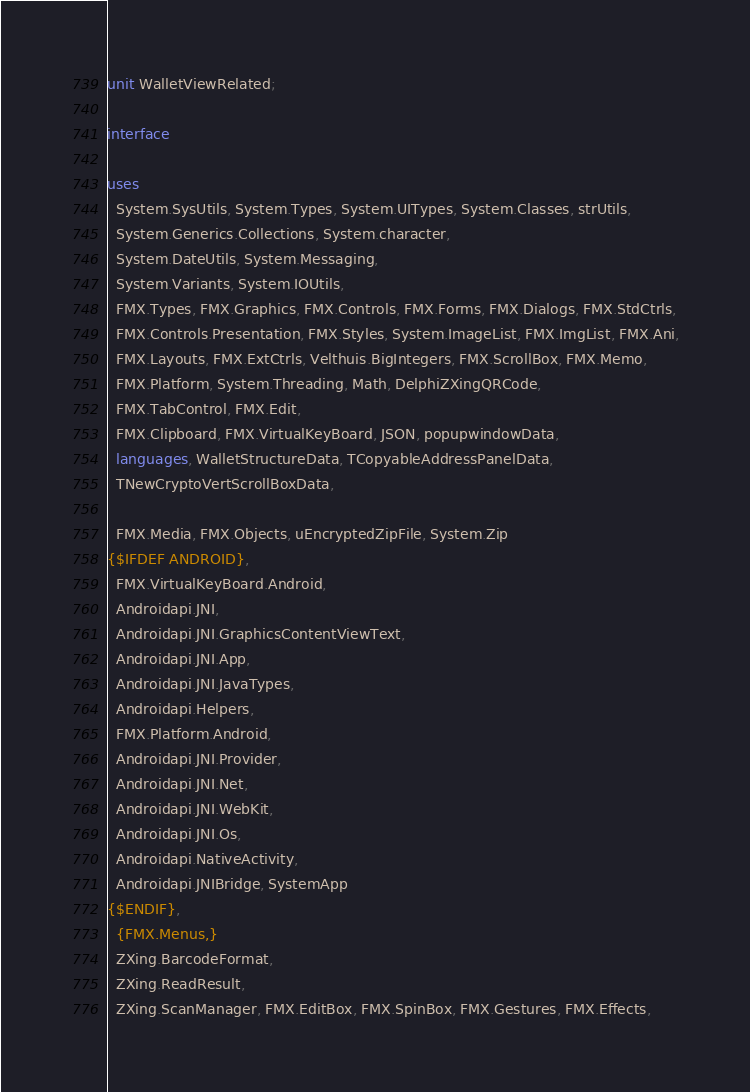Convert code to text. <code><loc_0><loc_0><loc_500><loc_500><_Pascal_>unit WalletViewRelated;

interface

uses
  System.SysUtils, System.Types, System.UITypes, System.Classes, strUtils,
  System.Generics.Collections, System.character,
  System.DateUtils, System.Messaging,
  System.Variants, System.IOUtils,
  FMX.Types, FMX.Graphics, FMX.Controls, FMX.Forms, FMX.Dialogs, FMX.StdCtrls,
  FMX.Controls.Presentation, FMX.Styles, System.ImageList, FMX.ImgList, FMX.Ani,
  FMX.Layouts, FMX.ExtCtrls, Velthuis.BigIntegers, FMX.ScrollBox, FMX.Memo,
  FMX.Platform, System.Threading, Math, DelphiZXingQRCode,
  FMX.TabControl, FMX.Edit,
  FMX.Clipboard, FMX.VirtualKeyBoard, JSON, popupwindowData,
  languages, WalletStructureData, TCopyableAddressPanelData,
  TNewCryptoVertScrollBoxData,

  FMX.Media, FMX.Objects, uEncryptedZipFile, System.Zip
{$IFDEF ANDROID},
  FMX.VirtualKeyBoard.Android,
  Androidapi.JNI,
  Androidapi.JNI.GraphicsContentViewText,
  Androidapi.JNI.App,
  Androidapi.JNI.JavaTypes,
  Androidapi.Helpers,
  FMX.Platform.Android,
  Androidapi.JNI.Provider,
  Androidapi.JNI.Net,
  Androidapi.JNI.WebKit,
  Androidapi.JNI.Os,
  Androidapi.NativeActivity,
  Androidapi.JNIBridge, SystemApp
{$ENDIF},
  {FMX.Menus,}
  ZXing.BarcodeFormat,
  ZXing.ReadResult,
  ZXing.ScanManager, FMX.EditBox, FMX.SpinBox, FMX.Gestures, FMX.Effects,</code> 